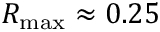<formula> <loc_0><loc_0><loc_500><loc_500>R _ { \max } \approx 0 . 2 5</formula> 